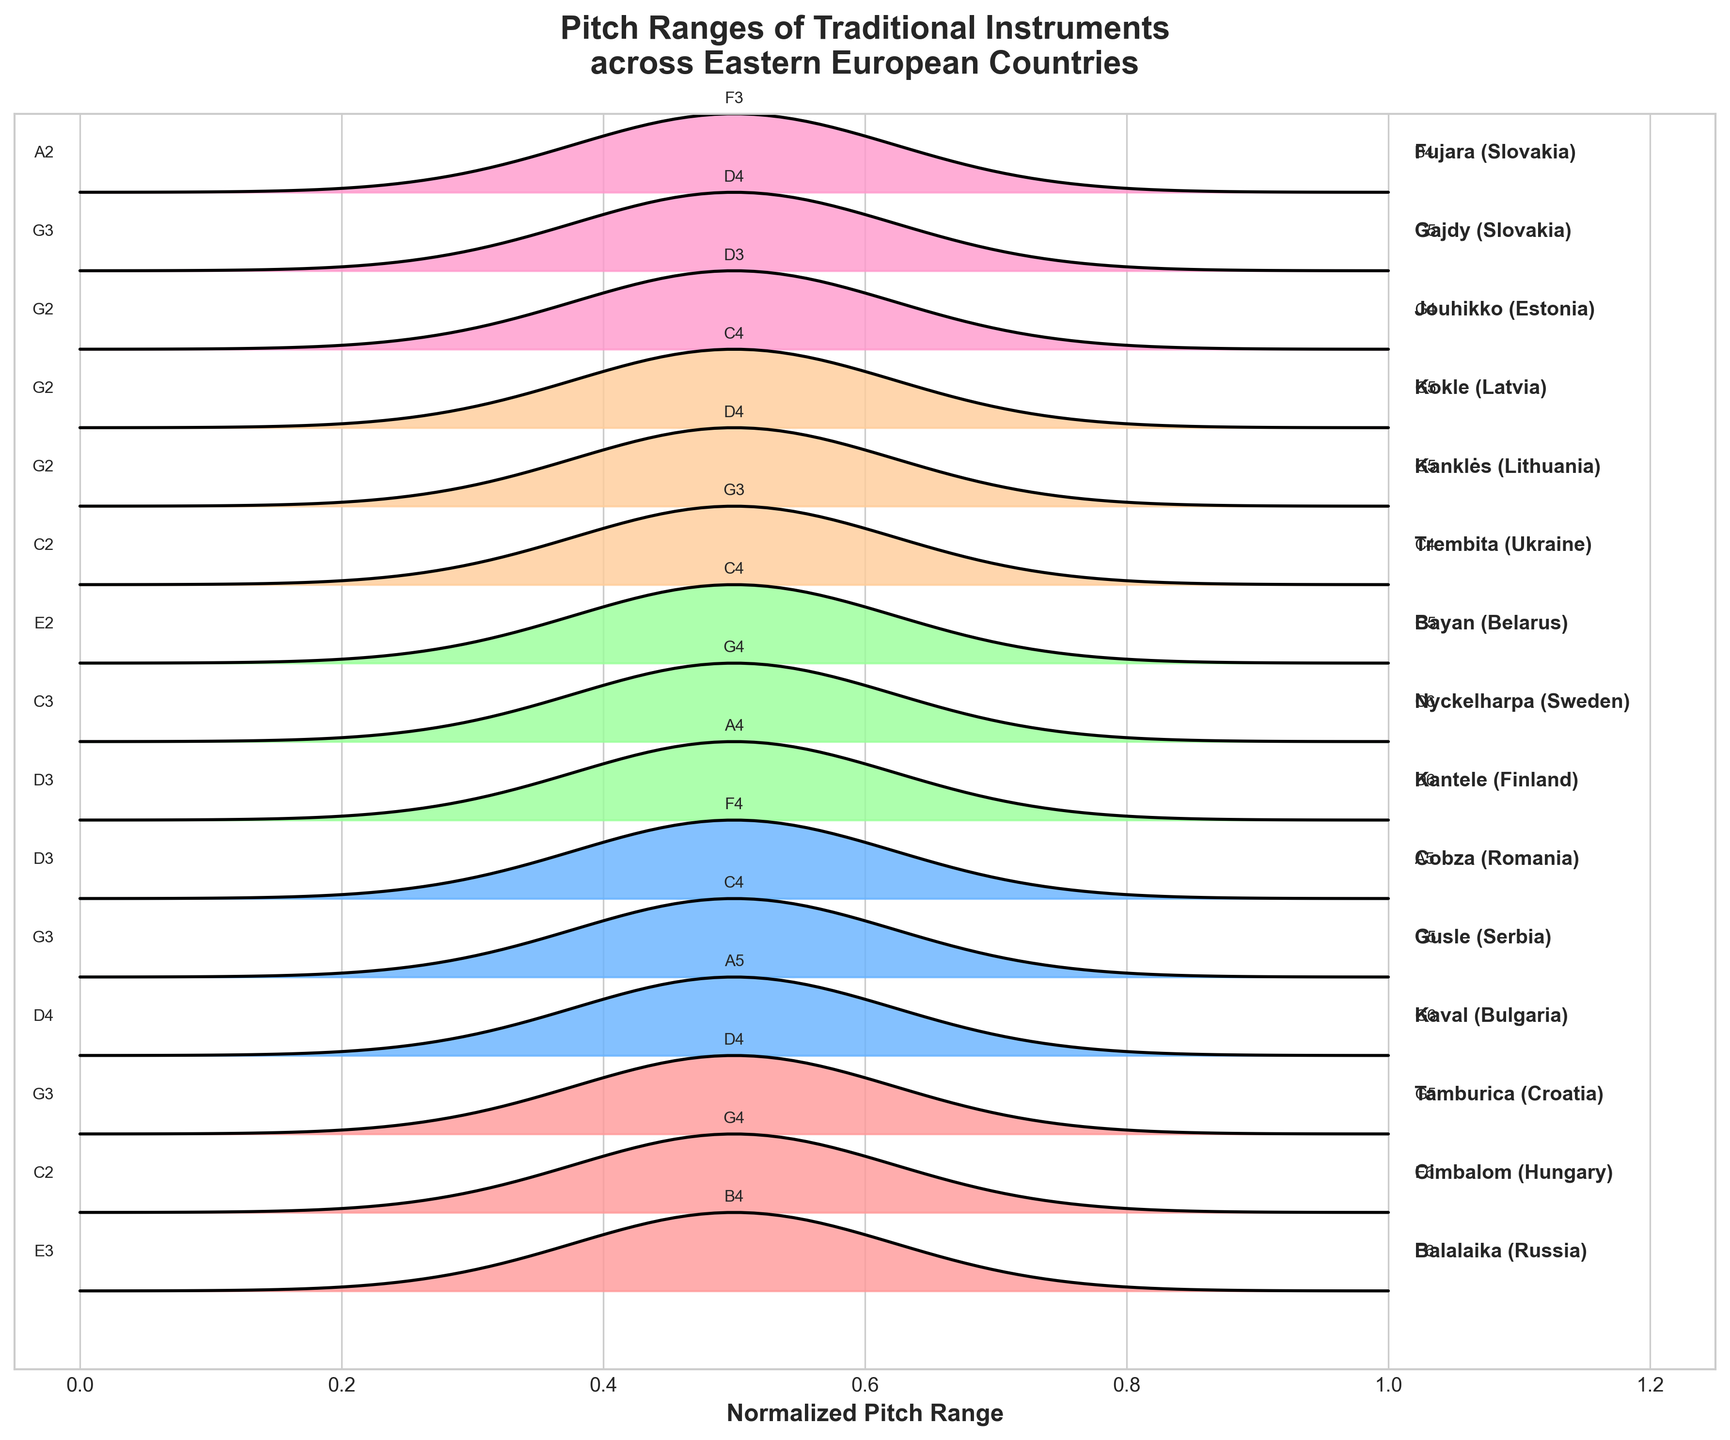What is the title of the plot? The title is usually placed at the top of the figure. In this case, it is written in bold and larger font.
Answer: Pitch Ranges of Traditional Instruments across Eastern European Countries How many different instruments are shown in the plot? Count the number of different instruments listed on the right side of the ridgeline plot. Each instrument has its own y-position in the plot.
Answer: 15 Which instrument has the highest maximum pitch and what is that pitch? Look at the labels for maximum pitch for each instrument along the far-right side of the plot. Identify the one with the highest value.
Answer: Kaval (G6) What is the minimum pitch of the Trembita from Ukraine? Find the label for the Trembita (Ukraine) along the y-axis, and then read the minimum pitch value directly to its left.
Answer: C2 Which two instruments have the exact same range (G2-G5)? Inspect the minimum and maximum pitches of each instrument listed on the right. Identify the pairs that span from G2 to G5.
Answer: Kanklės and Kokle Out of the instruments with peak pitch labeled, which one peaks the closest to the upper limit of its range? Look for the peak pitch notation above each ridge and compare its position relative to the maximum pitch in the same row. Identify the instrument with the peak pitch closest to its respective maximum.
Answer: Kaval (A5 out of G6) What's the average of the maximum pitches for the Slovakian instruments? Identify the maximum pitches for Gajdy and Fujara, which are from Slovakia, convert the pitches to their respective numeric values (G4=67, B4=71). Compute the average: (G5=79 + B4=71) / 2.
Answer: G4 (79) / 2 = G5 Which country has the most instruments represented in the plot? Count the instruments listed from each country and determine which country has the highest count.
Answer: Slovakia (2 instruments: Gajdy and Fujara) Among the instruments, which one has the narrowest pitch range? Calculate the pitch range for each instrument by finding the difference between their maximum and minimum pitches and identify the smallest range.
Answer: Jouhikko (G2 to G4, 2 steps) How many instruments have their peak pitch at exactly D4? Examine each instrument’s peak pitch displayed above the ridge and count those that have D4 as the peak.
Answer: 3 